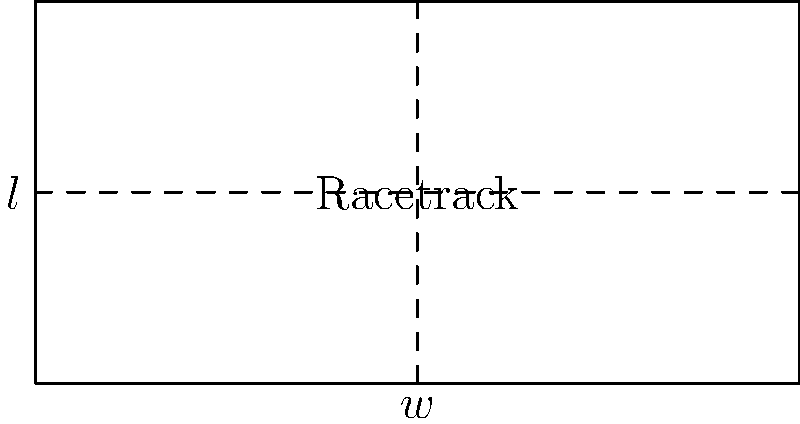A rectangular racetrack has a perimeter of 600 meters. The length of the track is 50 meters longer than twice its width. Calculate the area of the racetrack in square meters. Let's approach this step-by-step:

1) Let $w$ be the width and $l$ be the length of the racetrack.

2) Given that the perimeter is 600 meters:
   $$2l + 2w = 600$$

3) We're also told that the length is 50 meters longer than twice the width:
   $$l = 2w + 50$$

4) Substitute this into the perimeter equation:
   $$2(2w + 50) + 2w = 600$$
   $$4w + 100 + 2w = 600$$
   $$6w = 500$$
   $$w = \frac{500}{6} \approx 83.33$$

5) Now we can calculate the length:
   $$l = 2(83.33) + 50 = 216.67$$

6) The area of a rectangle is length times width:
   $$A = l * w = 216.67 * 83.33 \approx 18,055.56$$

Therefore, the area of the racetrack is approximately 18,055.56 square meters.
Answer: 18,055.56 sq meters 